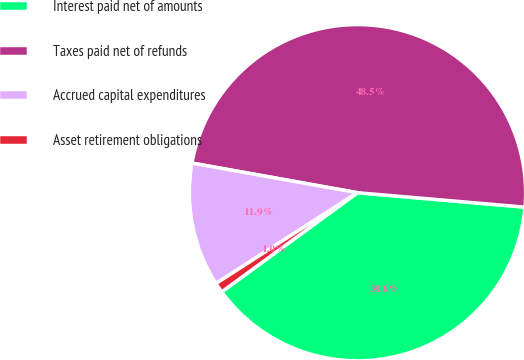<chart> <loc_0><loc_0><loc_500><loc_500><pie_chart><fcel>Interest paid net of amounts<fcel>Taxes paid net of refunds<fcel>Accrued capital expenditures<fcel>Asset retirement obligations<nl><fcel>38.59%<fcel>48.55%<fcel>11.9%<fcel>0.96%<nl></chart> 